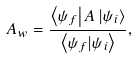<formula> <loc_0><loc_0><loc_500><loc_500>A _ { w } = \frac { \left \langle \psi _ { f } \right | A \left | \psi _ { i } \right \rangle } { \left \langle \psi _ { f } | \psi _ { i } \right \rangle } ,</formula> 